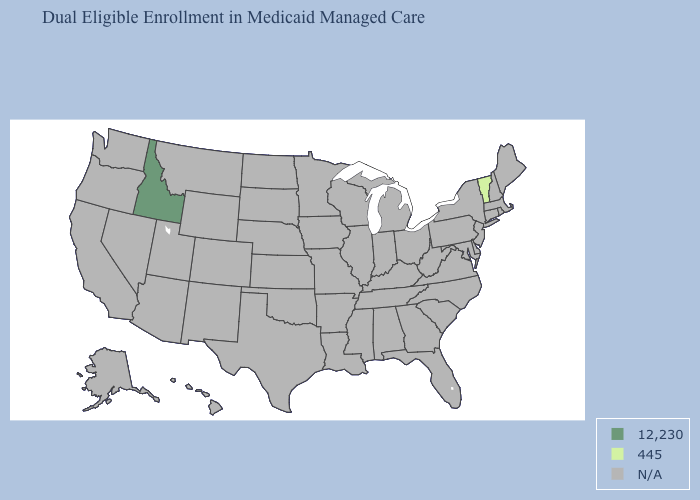Which states have the lowest value in the Northeast?
Answer briefly. Vermont. What is the value of Hawaii?
Short answer required. N/A. What is the value of Kansas?
Concise answer only. N/A. What is the value of Washington?
Concise answer only. N/A. What is the value of Arkansas?
Answer briefly. N/A. What is the value of New Mexico?
Keep it brief. N/A. Name the states that have a value in the range N/A?
Write a very short answer. Alabama, Alaska, Arizona, Arkansas, California, Colorado, Connecticut, Delaware, Florida, Georgia, Hawaii, Illinois, Indiana, Iowa, Kansas, Kentucky, Louisiana, Maine, Maryland, Massachusetts, Michigan, Minnesota, Mississippi, Missouri, Montana, Nebraska, Nevada, New Hampshire, New Jersey, New Mexico, New York, North Carolina, North Dakota, Ohio, Oklahoma, Oregon, Pennsylvania, Rhode Island, South Carolina, South Dakota, Tennessee, Texas, Utah, Virginia, Washington, West Virginia, Wisconsin, Wyoming. Which states have the lowest value in the USA?
Write a very short answer. Vermont. Name the states that have a value in the range N/A?
Give a very brief answer. Alabama, Alaska, Arizona, Arkansas, California, Colorado, Connecticut, Delaware, Florida, Georgia, Hawaii, Illinois, Indiana, Iowa, Kansas, Kentucky, Louisiana, Maine, Maryland, Massachusetts, Michigan, Minnesota, Mississippi, Missouri, Montana, Nebraska, Nevada, New Hampshire, New Jersey, New Mexico, New York, North Carolina, North Dakota, Ohio, Oklahoma, Oregon, Pennsylvania, Rhode Island, South Carolina, South Dakota, Tennessee, Texas, Utah, Virginia, Washington, West Virginia, Wisconsin, Wyoming. Which states have the highest value in the USA?
Be succinct. Idaho. What is the value of Rhode Island?
Write a very short answer. N/A. 